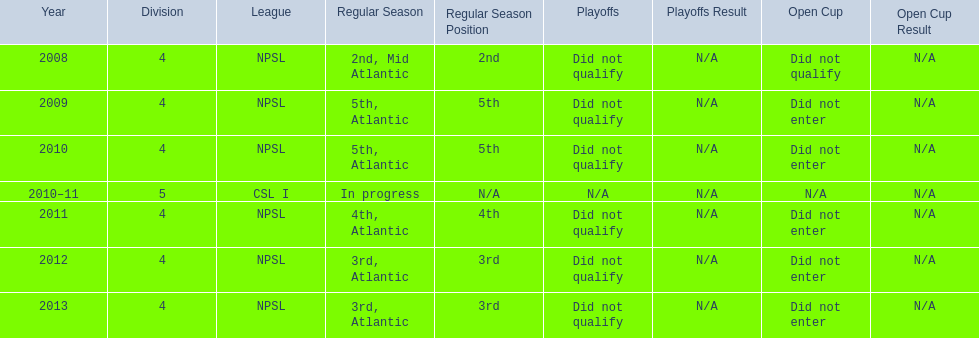What are all of the leagues? NPSL, NPSL, NPSL, CSL I, NPSL, NPSL, NPSL. Which league was played in the least? CSL I. 